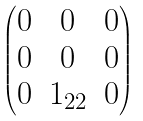<formula> <loc_0><loc_0><loc_500><loc_500>\begin{pmatrix} 0 & 0 & 0 \\ 0 & 0 & 0 \\ 0 & 1 _ { 2 2 } & 0 \end{pmatrix}</formula> 